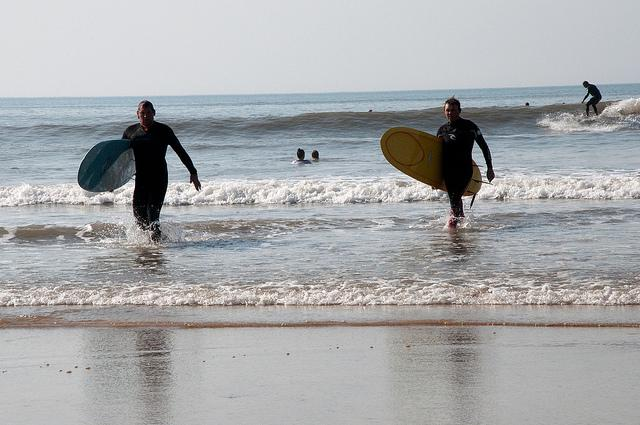What color is the surfboard held by the man walking up the beach on the right?

Choices:
A) yellow
B) blue
C) white
D) orange yellow 